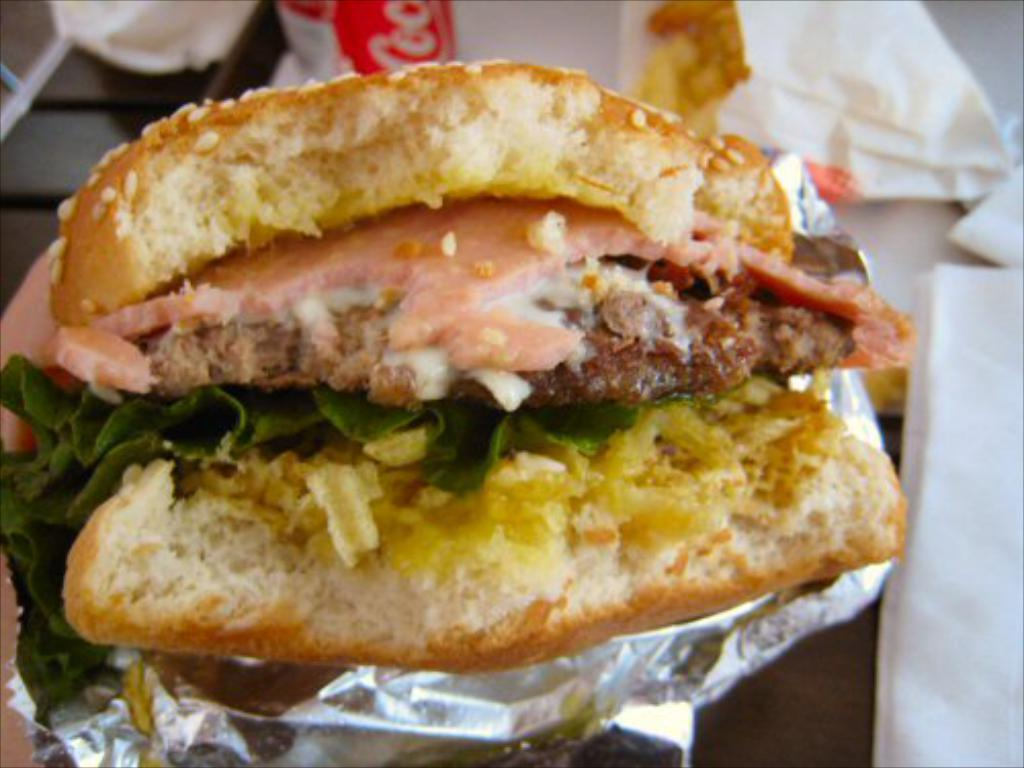What is the main food item in the image? There is a burger in the middle of the image. Where is the burger located in relation to other objects? The burger is in the middle of the image. What is at the bottom of the image? There is a table at the bottom of the image. What items can be found on the table? A napkin and tissues are present on the table, along with other objects. Can you see a rabbit hopping around the plate in the image? There is no plate or rabbit present in the image. 